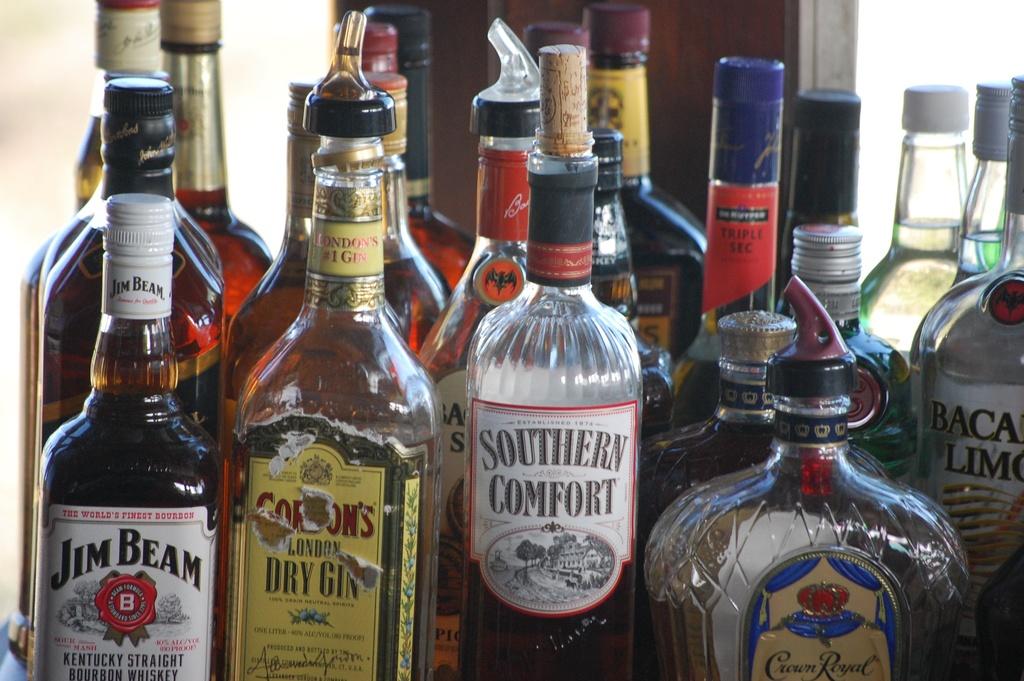What liquor is the bottom left?
Provide a succinct answer. Jim beam. 